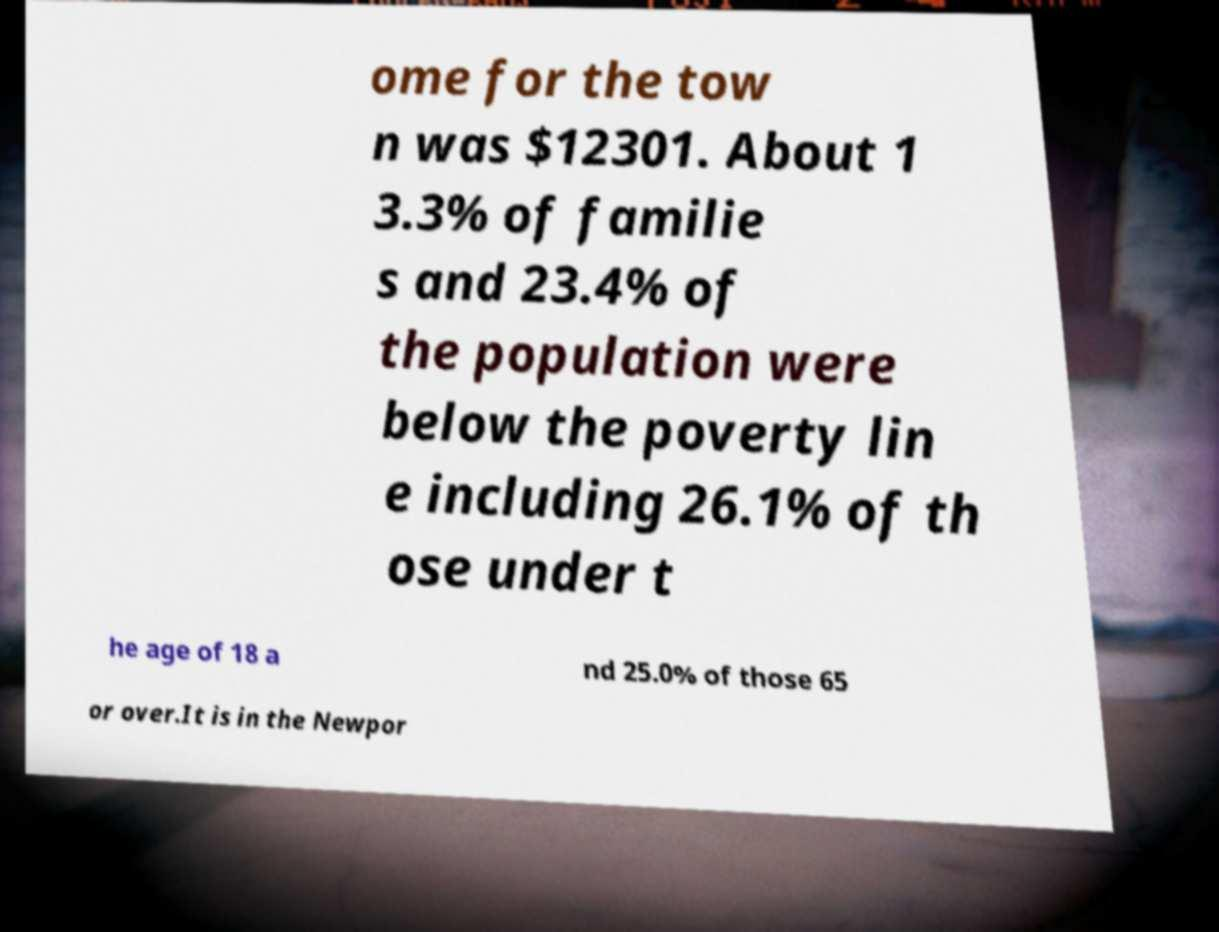I need the written content from this picture converted into text. Can you do that? ome for the tow n was $12301. About 1 3.3% of familie s and 23.4% of the population were below the poverty lin e including 26.1% of th ose under t he age of 18 a nd 25.0% of those 65 or over.It is in the Newpor 